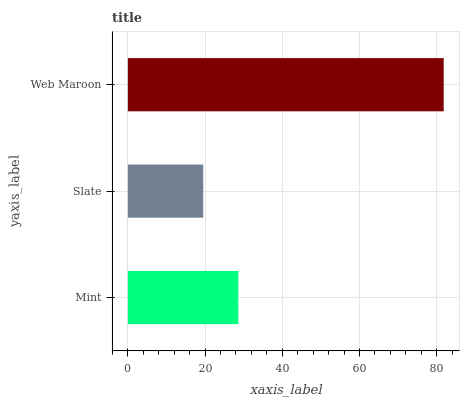Is Slate the minimum?
Answer yes or no. Yes. Is Web Maroon the maximum?
Answer yes or no. Yes. Is Web Maroon the minimum?
Answer yes or no. No. Is Slate the maximum?
Answer yes or no. No. Is Web Maroon greater than Slate?
Answer yes or no. Yes. Is Slate less than Web Maroon?
Answer yes or no. Yes. Is Slate greater than Web Maroon?
Answer yes or no. No. Is Web Maroon less than Slate?
Answer yes or no. No. Is Mint the high median?
Answer yes or no. Yes. Is Mint the low median?
Answer yes or no. Yes. Is Slate the high median?
Answer yes or no. No. Is Slate the low median?
Answer yes or no. No. 